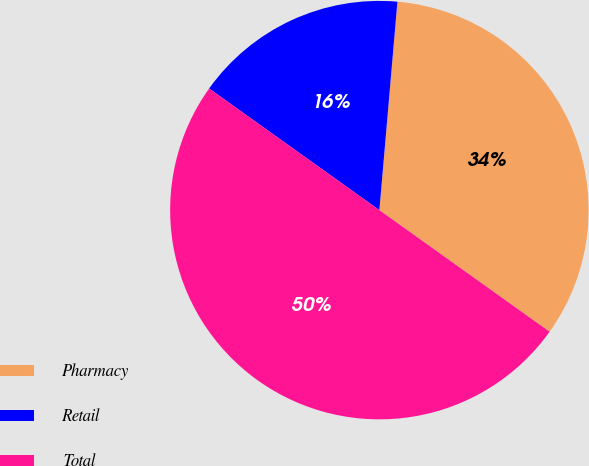Convert chart. <chart><loc_0><loc_0><loc_500><loc_500><pie_chart><fcel>Pharmacy<fcel>Retail<fcel>Total<nl><fcel>33.5%<fcel>16.5%<fcel>50.0%<nl></chart> 